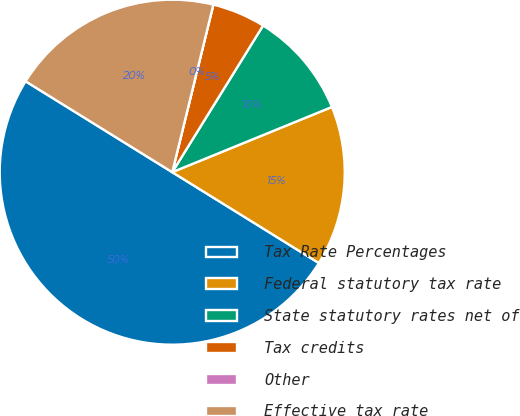Convert chart. <chart><loc_0><loc_0><loc_500><loc_500><pie_chart><fcel>Tax Rate Percentages<fcel>Federal statutory tax rate<fcel>State statutory rates net of<fcel>Tax credits<fcel>Other<fcel>Effective tax rate<nl><fcel>50.0%<fcel>15.0%<fcel>10.0%<fcel>5.0%<fcel>0.0%<fcel>20.0%<nl></chart> 